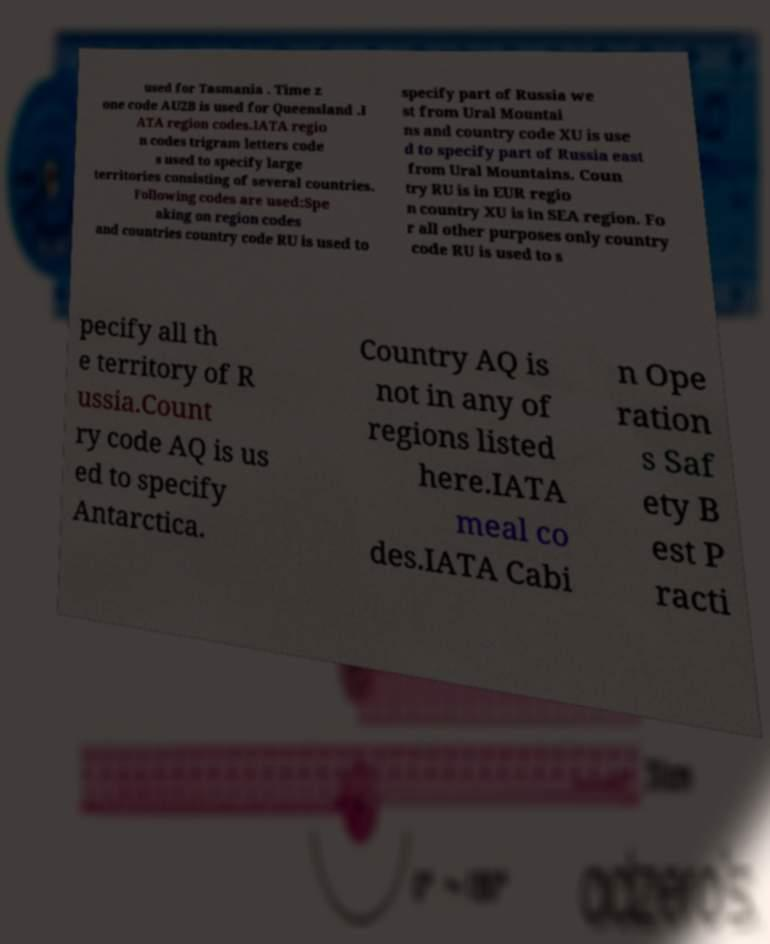What messages or text are displayed in this image? I need them in a readable, typed format. used for Tasmania . Time z one code AU2B is used for Queensland .I ATA region codes.IATA regio n codes trigram letters code s used to specify large territories consisting of several countries. Following codes are used:Spe aking on region codes and countries country code RU is used to specify part of Russia we st from Ural Mountai ns and country code XU is use d to specify part of Russia east from Ural Mountains. Coun try RU is in EUR regio n country XU is in SEA region. Fo r all other purposes only country code RU is used to s pecify all th e territory of R ussia.Count ry code AQ is us ed to specify Antarctica. Country AQ is not in any of regions listed here.IATA meal co des.IATA Cabi n Ope ration s Saf ety B est P racti 